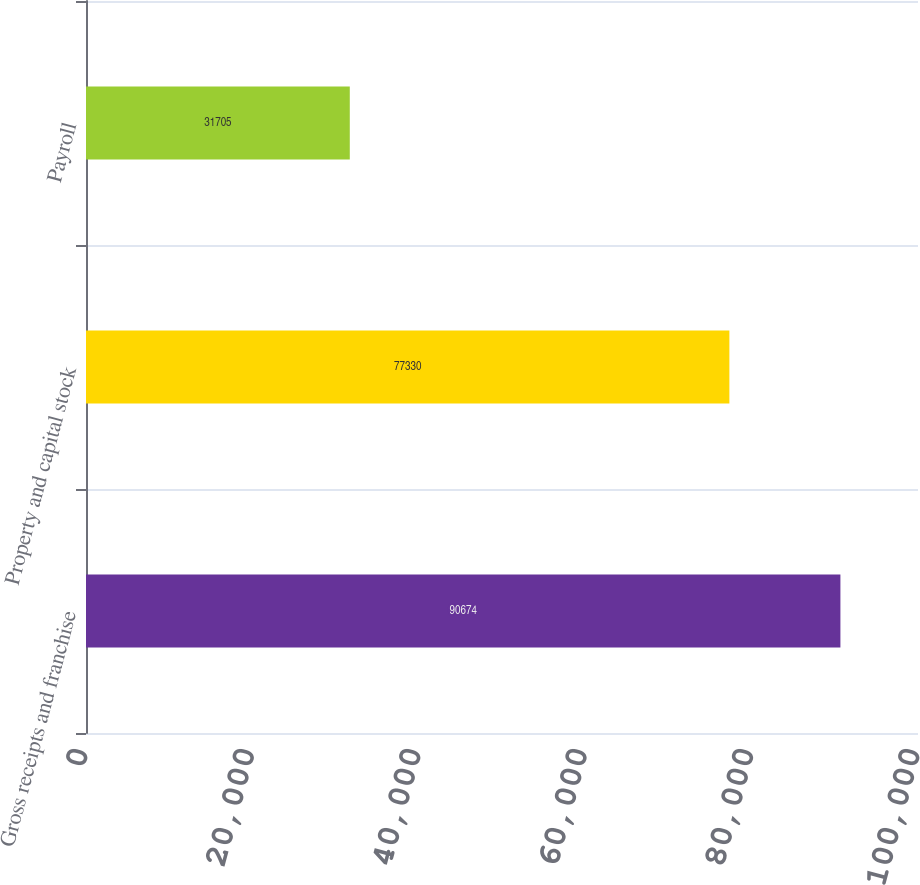Convert chart to OTSL. <chart><loc_0><loc_0><loc_500><loc_500><bar_chart><fcel>Gross receipts and franchise<fcel>Property and capital stock<fcel>Payroll<nl><fcel>90674<fcel>77330<fcel>31705<nl></chart> 